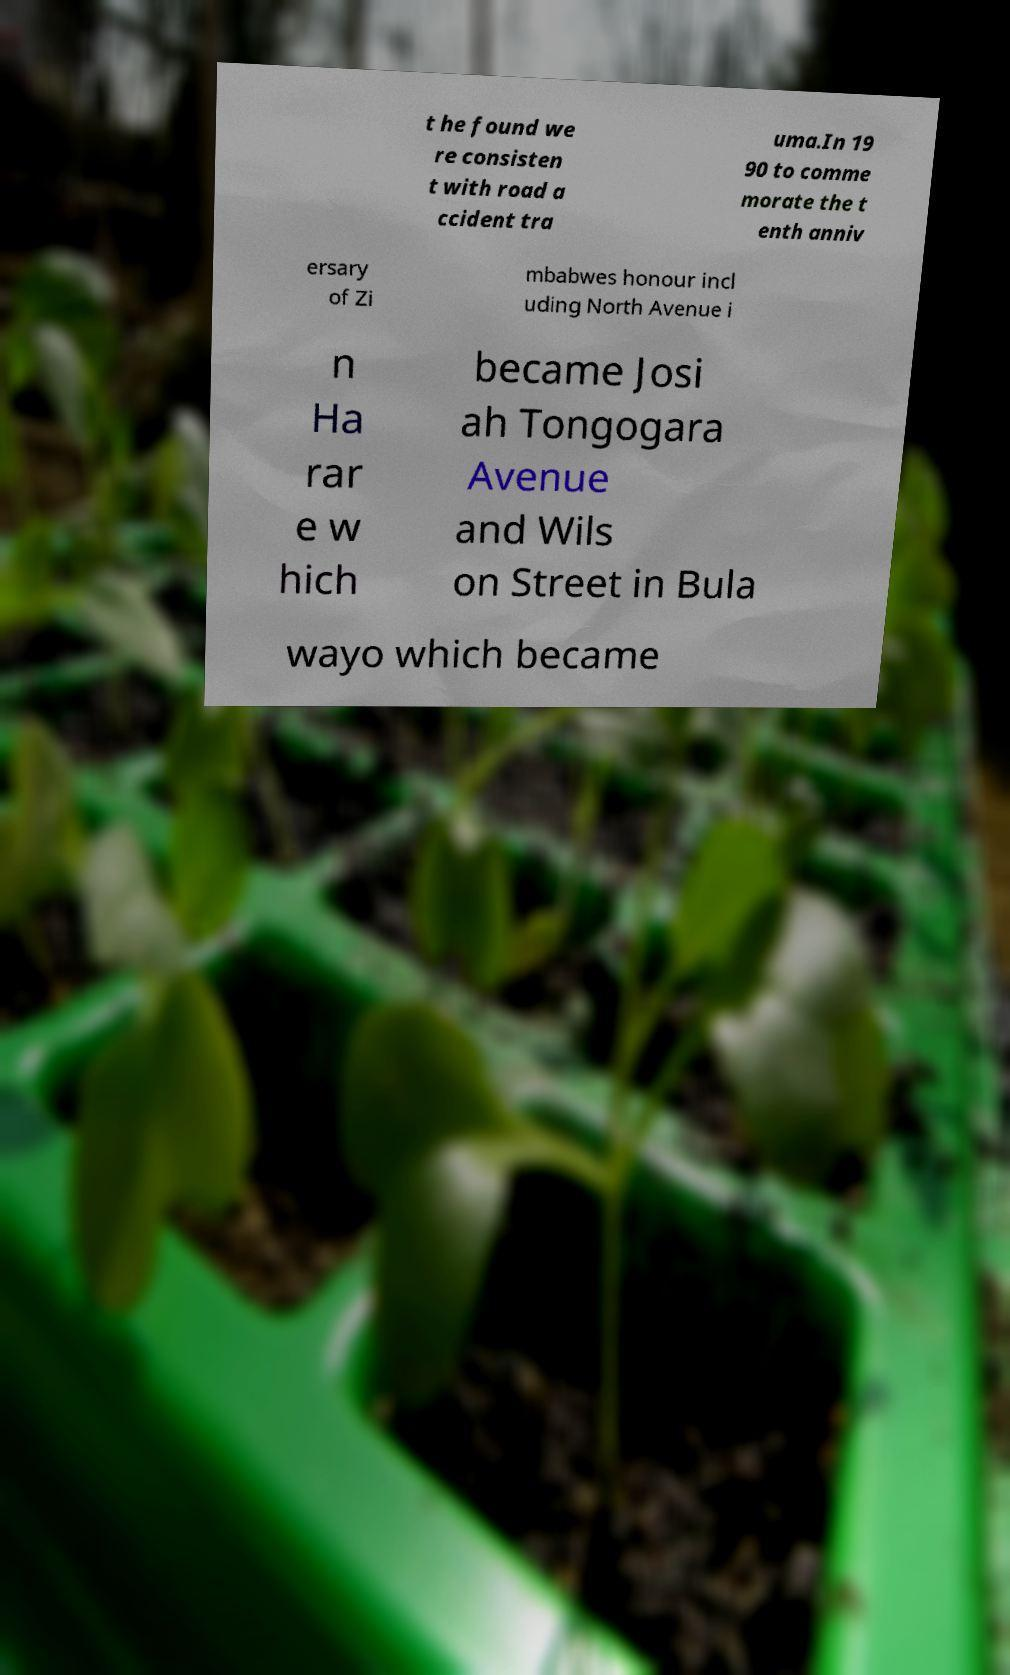Can you accurately transcribe the text from the provided image for me? t he found we re consisten t with road a ccident tra uma.In 19 90 to comme morate the t enth anniv ersary of Zi mbabwes honour incl uding North Avenue i n Ha rar e w hich became Josi ah Tongogara Avenue and Wils on Street in Bula wayo which became 